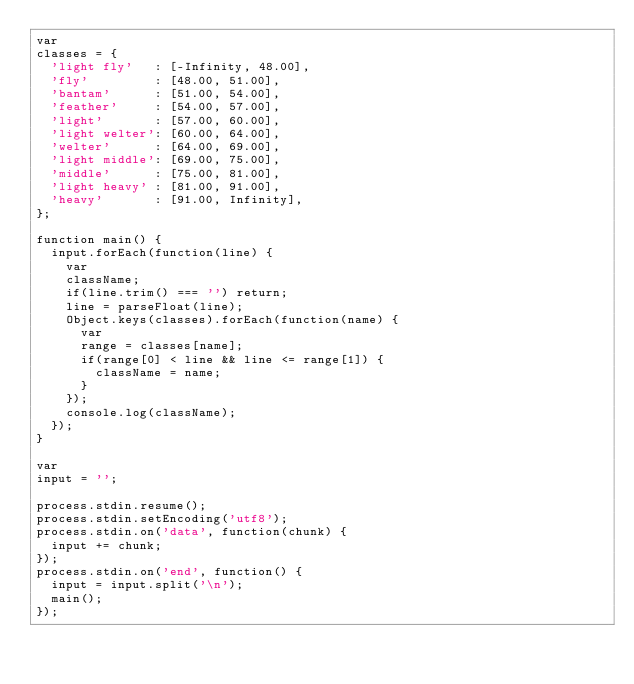Convert code to text. <code><loc_0><loc_0><loc_500><loc_500><_JavaScript_>var
classes = {
  'light fly'   : [-Infinity, 48.00],
  'fly'         : [48.00, 51.00],
  'bantam'      : [51.00, 54.00],
  'feather'     : [54.00, 57.00],
  'light'       : [57.00, 60.00],
  'light welter': [60.00, 64.00],
  'welter'      : [64.00, 69.00],
  'light middle': [69.00, 75.00],
  'middle'      : [75.00, 81.00],
  'light heavy' : [81.00, 91.00],
  'heavy'       : [91.00, Infinity],
};

function main() {
  input.forEach(function(line) {
    var
    className;
    if(line.trim() === '') return;
    line = parseFloat(line);
    Object.keys(classes).forEach(function(name) {
      var
      range = classes[name];
      if(range[0] < line && line <= range[1]) {
        className = name;
      }
    });
    console.log(className);
  });
}

var
input = '';

process.stdin.resume();
process.stdin.setEncoding('utf8');
process.stdin.on('data', function(chunk) {
  input += chunk;
});
process.stdin.on('end', function() {
  input = input.split('\n');
  main();
});</code> 